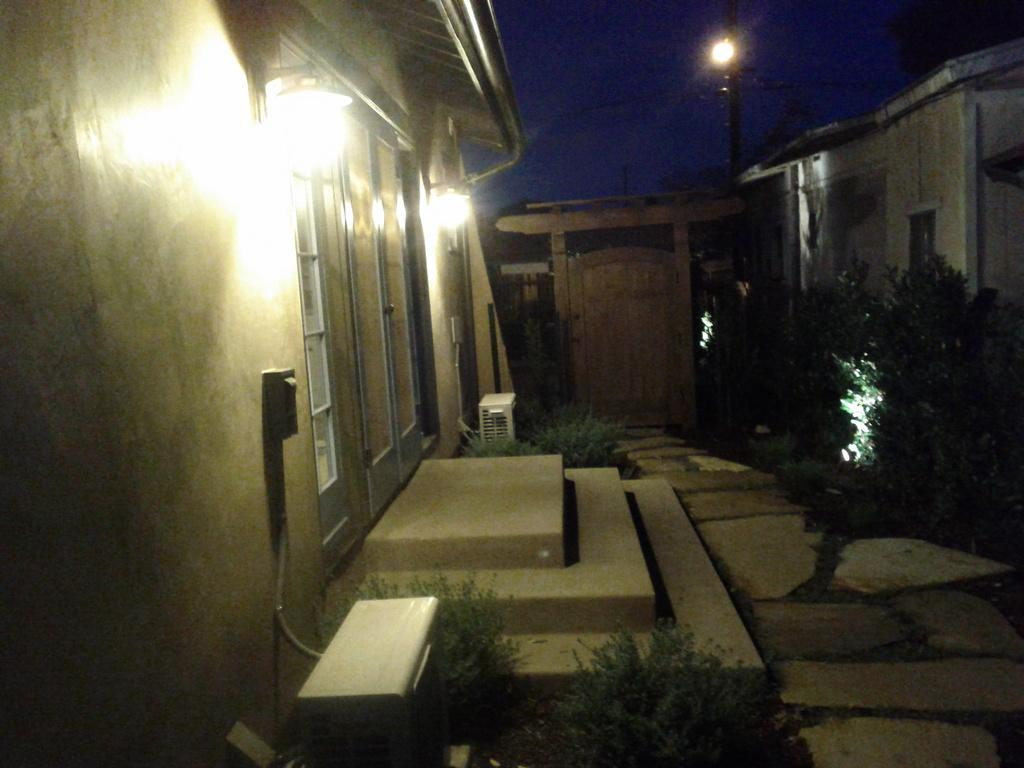What structure is located on the left side of the image? There is a house on the left side of the image. What feature of the house is mentioned in the facts? The house has lights. What can be seen on the right side of the image? There is a path on the right side of the image. What other elements are visible in the background of the image? There is a door and a light pole in the background of the image. What is visible at the top of the image? The sky is visible in the image. What type of reward can be seen hanging from the door in the image? There is no reward hanging from the door in the image; it is a door in the background of the image. Can you tell me how many ducks are sitting on the light pole in the image? There are no ducks present in the image; the light pole is in the background of the image. 